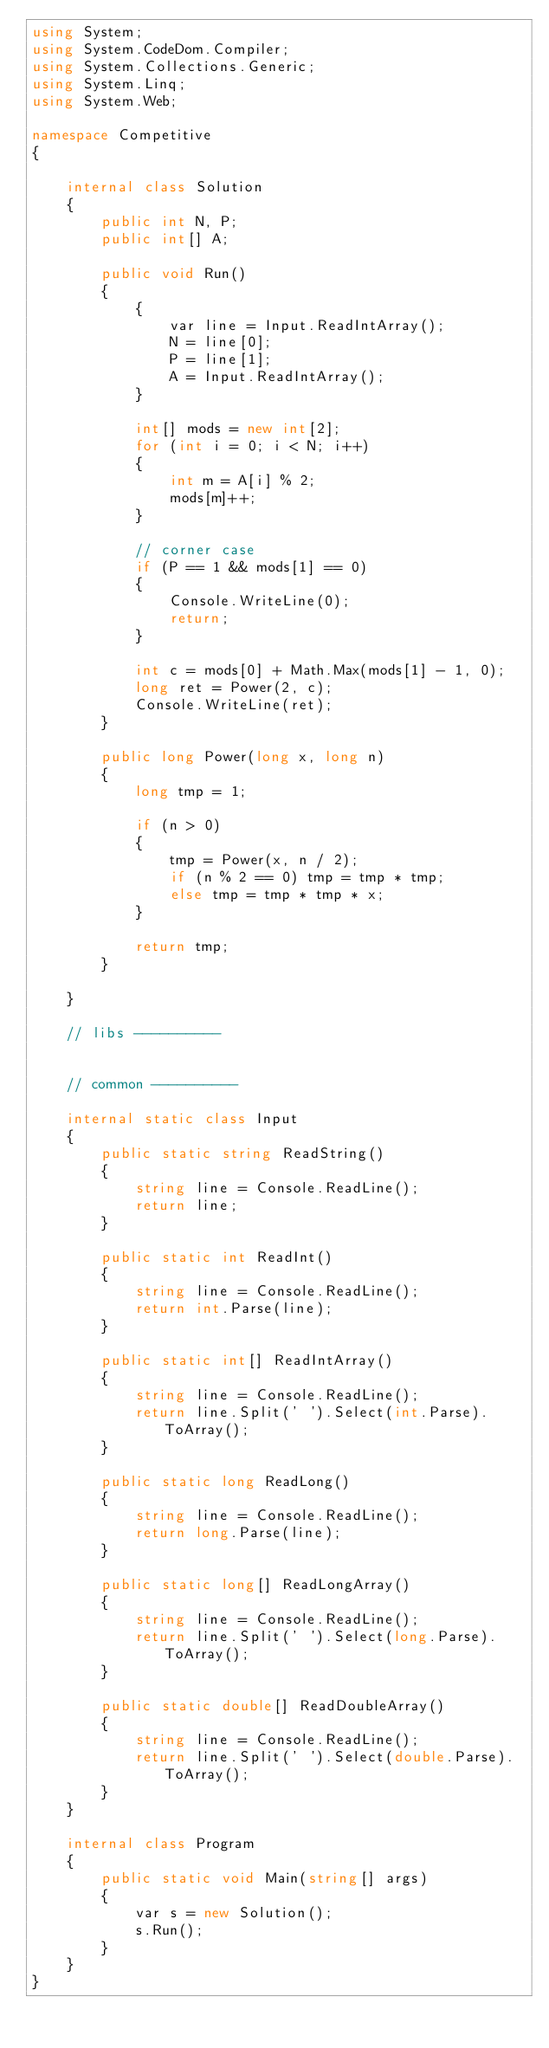<code> <loc_0><loc_0><loc_500><loc_500><_C#_>using System;
using System.CodeDom.Compiler;
using System.Collections.Generic;
using System.Linq;
using System.Web;

namespace Competitive
{

    internal class Solution
    {
        public int N, P;
        public int[] A;

        public void Run()
        {
            {
                var line = Input.ReadIntArray();
                N = line[0];
                P = line[1];
                A = Input.ReadIntArray();
            }

            int[] mods = new int[2];
            for (int i = 0; i < N; i++)
            {
                int m = A[i] % 2;
                mods[m]++;
            }

            // corner case
            if (P == 1 && mods[1] == 0)
            {
                Console.WriteLine(0);
                return;
            }

            int c = mods[0] + Math.Max(mods[1] - 1, 0);
            long ret = Power(2, c);
            Console.WriteLine(ret);
        }

        public long Power(long x, long n)
        {
            long tmp = 1;

            if (n > 0)
            {
                tmp = Power(x, n / 2);
                if (n % 2 == 0) tmp = tmp * tmp;
                else tmp = tmp * tmp * x;
            }

            return tmp;
        }

    }

    // libs ----------


    // common ----------

    internal static class Input
    {
        public static string ReadString()
        {
            string line = Console.ReadLine();
            return line;
        }

        public static int ReadInt()
        {
            string line = Console.ReadLine();
            return int.Parse(line);
        }

        public static int[] ReadIntArray()
        {
            string line = Console.ReadLine();
            return line.Split(' ').Select(int.Parse).ToArray();
        }

        public static long ReadLong()
        {
            string line = Console.ReadLine();
            return long.Parse(line);
        }

        public static long[] ReadLongArray()
        {
            string line = Console.ReadLine();
            return line.Split(' ').Select(long.Parse).ToArray();
        }

        public static double[] ReadDoubleArray()
        {
            string line = Console.ReadLine();
            return line.Split(' ').Select(double.Parse).ToArray();
        }
    }

    internal class Program
    {
        public static void Main(string[] args)
        {
            var s = new Solution();
            s.Run();
        }
    }
}</code> 